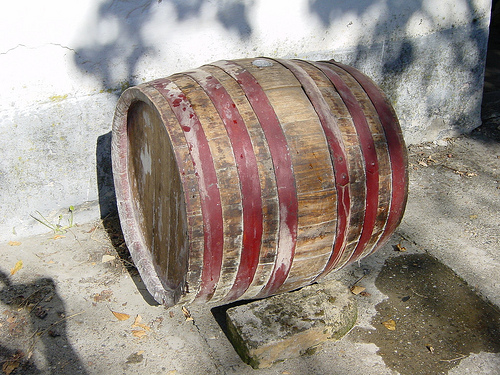<image>
Can you confirm if the barrel is to the right of the rock? No. The barrel is not to the right of the rock. The horizontal positioning shows a different relationship. 